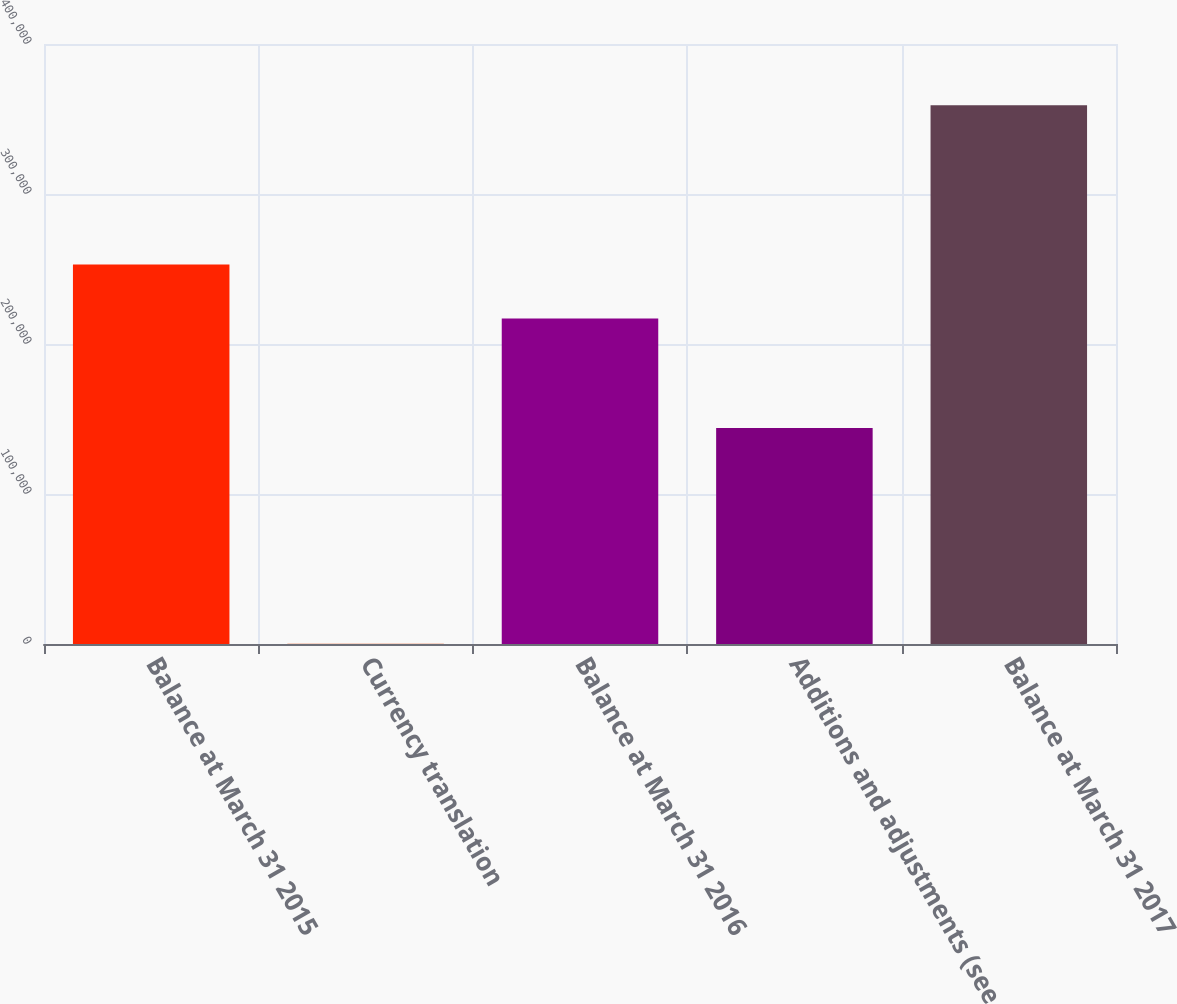Convert chart. <chart><loc_0><loc_0><loc_500><loc_500><bar_chart><fcel>Balance at March 31 2015<fcel>Currency translation<fcel>Balance at March 31 2016<fcel>Additions and adjustments (see<fcel>Balance at March 31 2017<nl><fcel>252971<fcel>208<fcel>217080<fcel>143952<fcel>359115<nl></chart> 